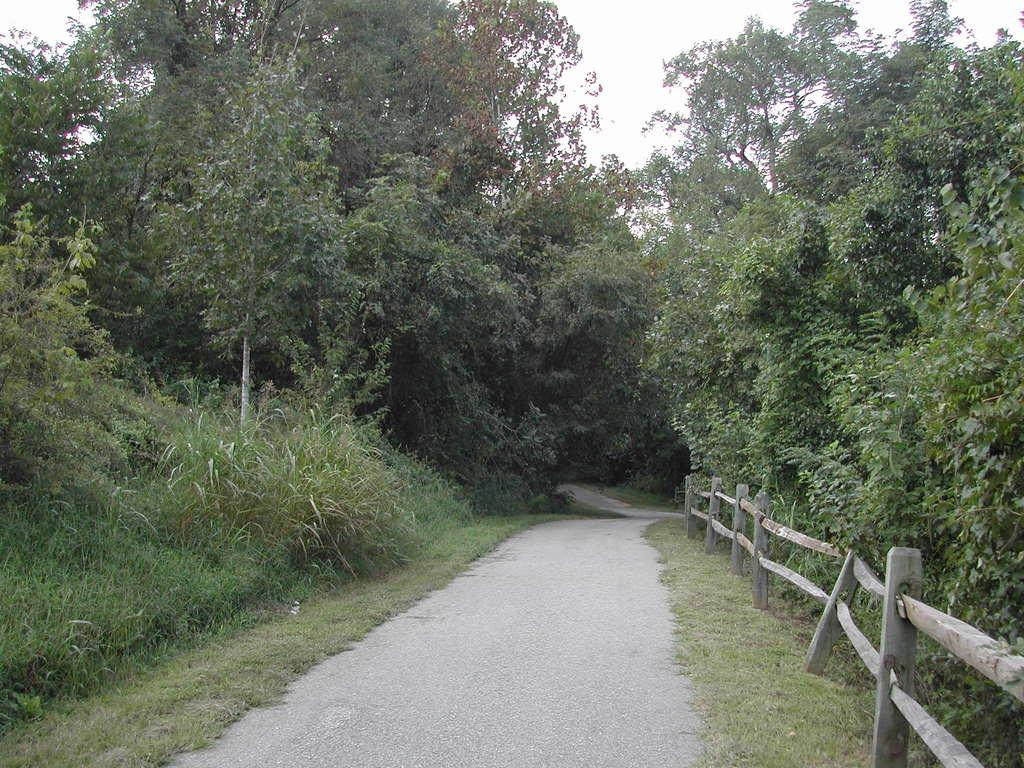What is the main feature of the image? There is a road in the image. What can be seen on the right side of the road? There is a wooden railing on the right side of the road. What type of vegetation is present on the land? There are plants and grass on the land. What is visible in the background of the image? Trees and the sky are visible in the background of the image. What is the process of the trees growing in the image? The image does not show the process of the trees growing; it only shows the trees as they currently appear. Can you walk on the sky visible in the background of the image? No, the sky is not a solid surface that can be walked on; it is the atmosphere surrounding the Earth. 